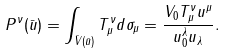Convert formula to latex. <formula><loc_0><loc_0><loc_500><loc_500>P ^ { \nu } ( \bar { u } ) = \int _ { \bar { V } ( \bar { u } ) } T ^ { \nu } _ { \mu } d \sigma _ { \mu } = \frac { V _ { 0 } T ^ { \nu } _ { \mu } u ^ { \mu } } { u _ { 0 } ^ { \lambda } u _ { \lambda } } .</formula> 